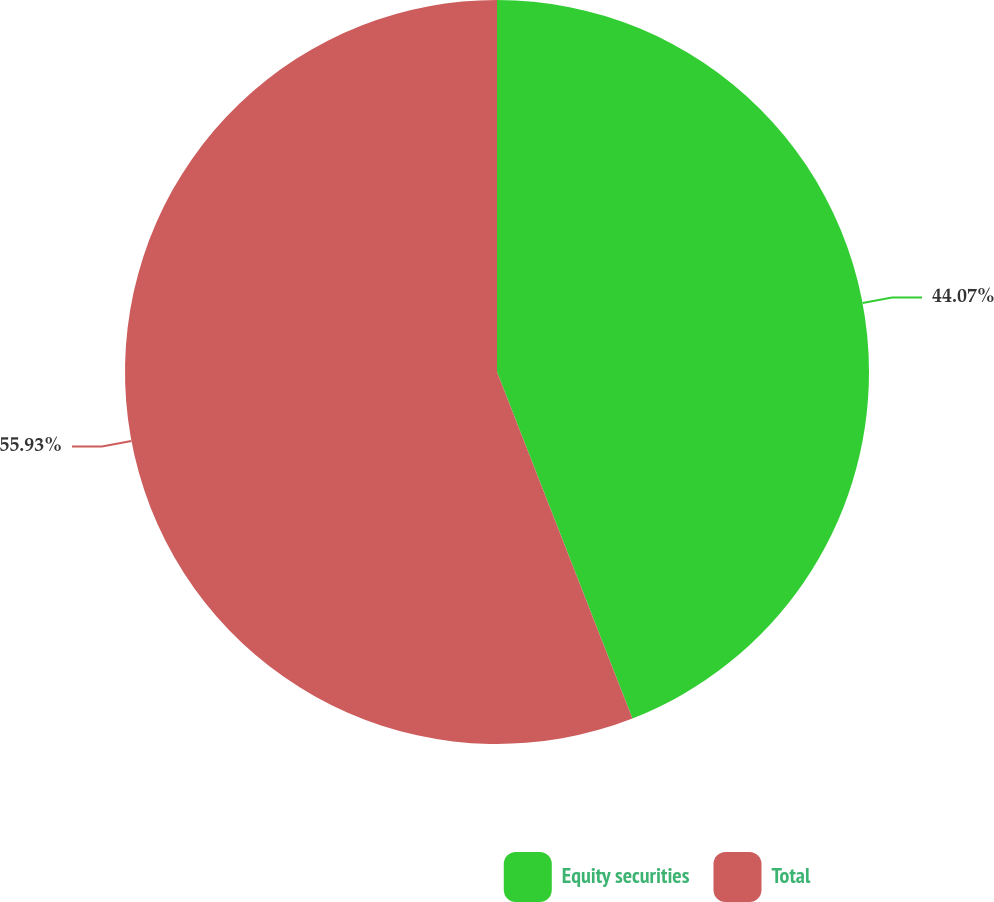Convert chart. <chart><loc_0><loc_0><loc_500><loc_500><pie_chart><fcel>Equity securities<fcel>Total<nl><fcel>44.07%<fcel>55.93%<nl></chart> 